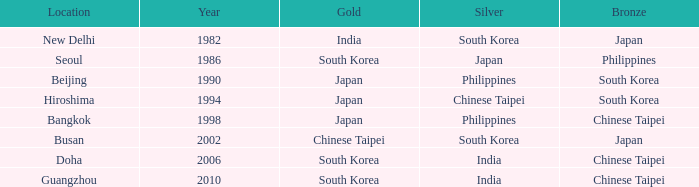Which Bronze has a Year smaller than 1994, and a Silver of south korea? Japan. 